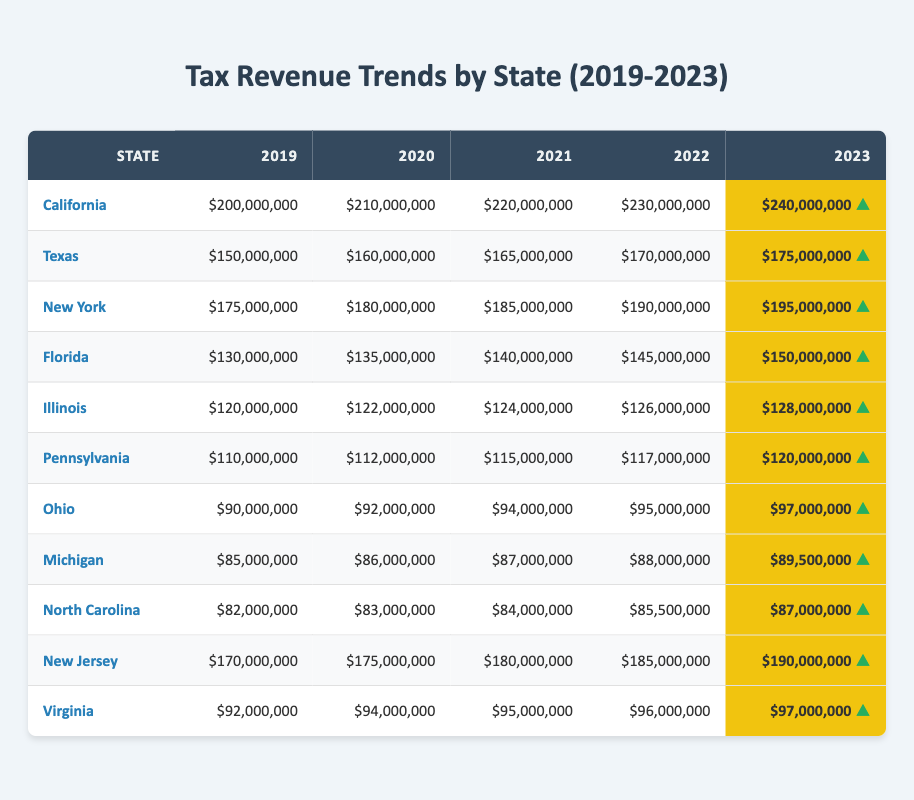What was the tax revenue for California in 2023? In the table, the tax revenue for California in 2023 is listed under the corresponding year, which shows $240,000,000.
Answer: $240,000,000 Which state had the lowest tax revenue in 2019? By comparing the values in the 2019 column, Ohio has the lowest tax revenue at $90,000,000.
Answer: Ohio What is the total tax revenue for Texas over the five years? To find the total for Texas, add the yearly revenues: $150,000,000 + $160,000,000 + $165,000,000 + $170,000,000 + $175,000,000 = $820,000,000.
Answer: $820,000,000 Did New York's tax revenue increase every year from 2019 to 2023? Yes, by observing the numbers for New York from 2019 ($175,000,000) to 2023 ($195,000,000), it shows a consistent increase each year.
Answer: Yes What was the average tax revenue for Florida over the five fiscal years? The average is calculated by summing the revenues ($130,000,000 + $135,000,000 + $140,000,000 + $145,000,000 + $150,000,000 = $700,000,000) and dividing by 5, which gives $700,000,000 / 5 = $140,000,000.
Answer: $140,000,000 How much did Illinois's tax revenue increase from 2019 to 2023? The increase is calculated by subtracting the 2019 revenue ($120,000,000) from the 2023 revenue ($128,000,000), which results in $128,000,000 - $120,000,000 = $8,000,000.
Answer: $8,000,000 Which state showed the highest tax revenue for the fiscal year 2022? By reviewing the 2022 column, California has the highest tax revenue at $230,000,000 compared to other states.
Answer: California Is the tax revenue trend for Pennsylvania consistent over the five years? Yes, the revenue in Pennsylvania consistently increased each year: from $110,000,000 in 2019 to $120,000,000 in 2023.
Answer: Yes What percentage of the total tax revenue for New Jersey in 2023 does it represent compared to California's 2023 revenue? The total for New Jersey in 2023 is $190,000,000. To find the percentage, use the formula: ($190,000,000 / $240,000,000) * 100, which equals approximately 79.17%.
Answer: 79.17% Which two states had the closest tax revenues in 2023? In 2023, the revenues for Texas ($175,000,000) and New York ($195,000,000) are the closest, differing by $20,000,000.
Answer: Texas and New York How did tax revenue in Virginia compare to that of Michigan in 2023? Virginia had $97,000,000, while Michigan had $89,500,000. Thus, Virginia's tax revenue was $7,500,000 higher than Michigan's in 2023.
Answer: Virginia was higher by $7,500,000 